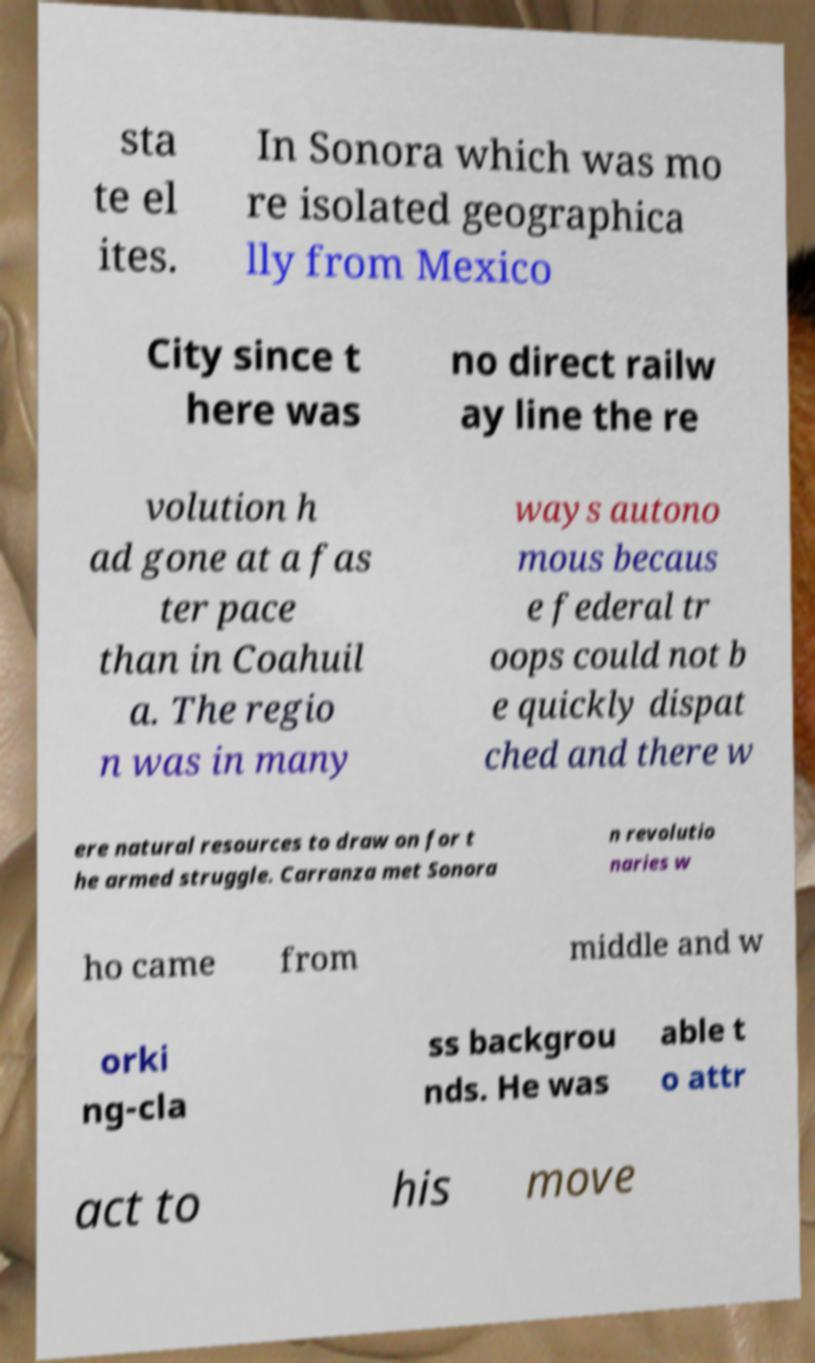Please read and relay the text visible in this image. What does it say? sta te el ites. In Sonora which was mo re isolated geographica lly from Mexico City since t here was no direct railw ay line the re volution h ad gone at a fas ter pace than in Coahuil a. The regio n was in many ways autono mous becaus e federal tr oops could not b e quickly dispat ched and there w ere natural resources to draw on for t he armed struggle. Carranza met Sonora n revolutio naries w ho came from middle and w orki ng-cla ss backgrou nds. He was able t o attr act to his move 